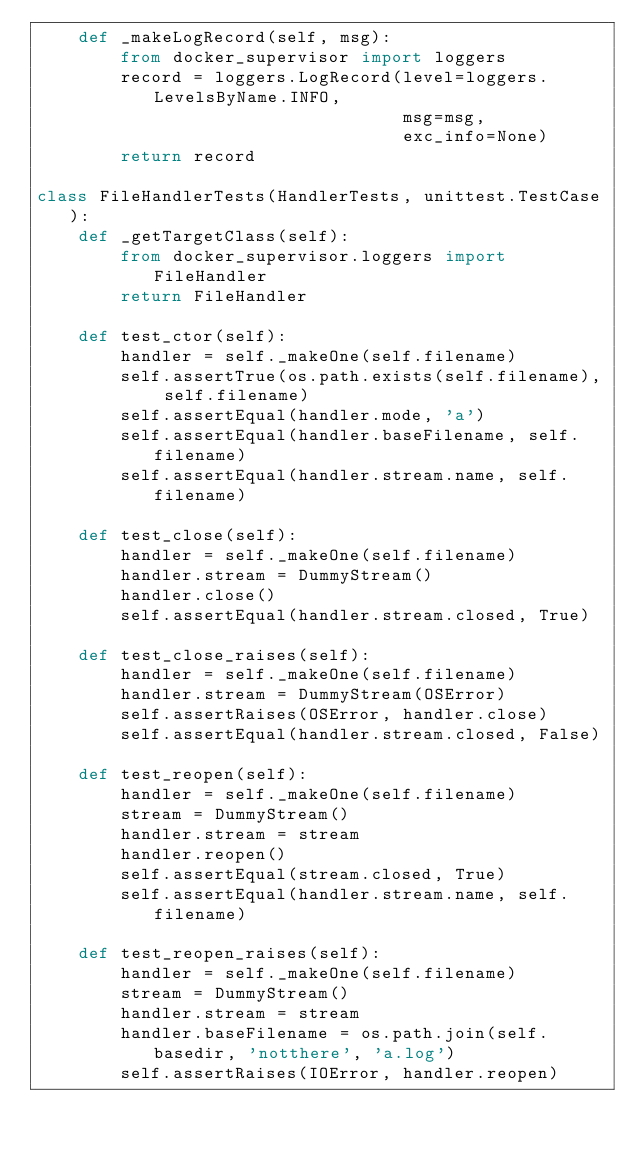<code> <loc_0><loc_0><loc_500><loc_500><_Python_>    def _makeLogRecord(self, msg):
        from docker_supervisor import loggers
        record = loggers.LogRecord(level=loggers.LevelsByName.INFO,
                                   msg=msg,
                                   exc_info=None)
        return record

class FileHandlerTests(HandlerTests, unittest.TestCase):
    def _getTargetClass(self):
        from docker_supervisor.loggers import FileHandler
        return FileHandler

    def test_ctor(self):
        handler = self._makeOne(self.filename)
        self.assertTrue(os.path.exists(self.filename), self.filename)
        self.assertEqual(handler.mode, 'a')
        self.assertEqual(handler.baseFilename, self.filename)
        self.assertEqual(handler.stream.name, self.filename)

    def test_close(self):
        handler = self._makeOne(self.filename)
        handler.stream = DummyStream()
        handler.close()
        self.assertEqual(handler.stream.closed, True)

    def test_close_raises(self):
        handler = self._makeOne(self.filename)
        handler.stream = DummyStream(OSError)
        self.assertRaises(OSError, handler.close)
        self.assertEqual(handler.stream.closed, False)

    def test_reopen(self):
        handler = self._makeOne(self.filename)
        stream = DummyStream()
        handler.stream = stream
        handler.reopen()
        self.assertEqual(stream.closed, True)
        self.assertEqual(handler.stream.name, self.filename)

    def test_reopen_raises(self):
        handler = self._makeOne(self.filename)
        stream = DummyStream()
        handler.stream = stream
        handler.baseFilename = os.path.join(self.basedir, 'notthere', 'a.log')
        self.assertRaises(IOError, handler.reopen)</code> 